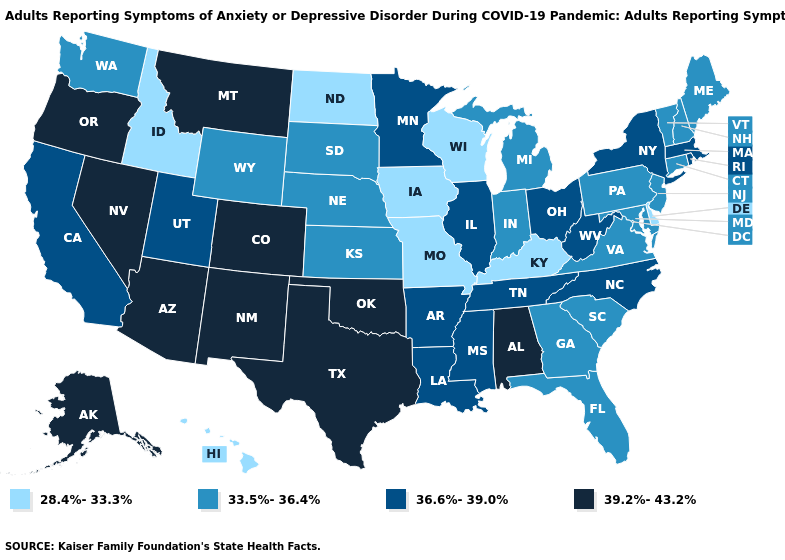Does Texas have a lower value than Alabama?
Concise answer only. No. Does California have the same value as Massachusetts?
Write a very short answer. Yes. Does New Hampshire have the lowest value in the Northeast?
Give a very brief answer. Yes. Does the first symbol in the legend represent the smallest category?
Answer briefly. Yes. Does Arizona have the highest value in the USA?
Be succinct. Yes. Name the states that have a value in the range 39.2%-43.2%?
Write a very short answer. Alabama, Alaska, Arizona, Colorado, Montana, Nevada, New Mexico, Oklahoma, Oregon, Texas. What is the highest value in states that border Oklahoma?
Be succinct. 39.2%-43.2%. Name the states that have a value in the range 39.2%-43.2%?
Short answer required. Alabama, Alaska, Arizona, Colorado, Montana, Nevada, New Mexico, Oklahoma, Oregon, Texas. What is the value of Pennsylvania?
Quick response, please. 33.5%-36.4%. Among the states that border Michigan , does Indiana have the lowest value?
Write a very short answer. No. Does North Carolina have the highest value in the USA?
Keep it brief. No. Does Wisconsin have the lowest value in the USA?
Keep it brief. Yes. Name the states that have a value in the range 33.5%-36.4%?
Answer briefly. Connecticut, Florida, Georgia, Indiana, Kansas, Maine, Maryland, Michigan, Nebraska, New Hampshire, New Jersey, Pennsylvania, South Carolina, South Dakota, Vermont, Virginia, Washington, Wyoming. Among the states that border Minnesota , which have the highest value?
Keep it brief. South Dakota. Name the states that have a value in the range 33.5%-36.4%?
Be succinct. Connecticut, Florida, Georgia, Indiana, Kansas, Maine, Maryland, Michigan, Nebraska, New Hampshire, New Jersey, Pennsylvania, South Carolina, South Dakota, Vermont, Virginia, Washington, Wyoming. 